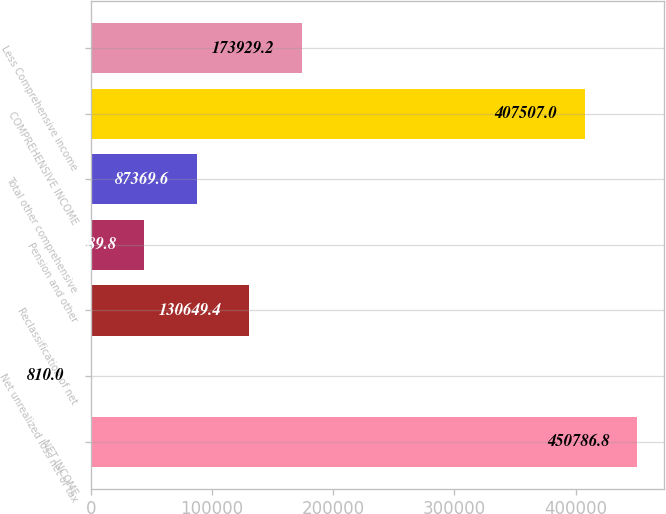<chart> <loc_0><loc_0><loc_500><loc_500><bar_chart><fcel>NET INCOME<fcel>Net unrealized loss net of tax<fcel>Reclassification of net<fcel>Pension and other<fcel>Total other comprehensive<fcel>COMPREHENSIVE INCOME<fcel>Less Comprehensive income<nl><fcel>450787<fcel>810<fcel>130649<fcel>44089.8<fcel>87369.6<fcel>407507<fcel>173929<nl></chart> 